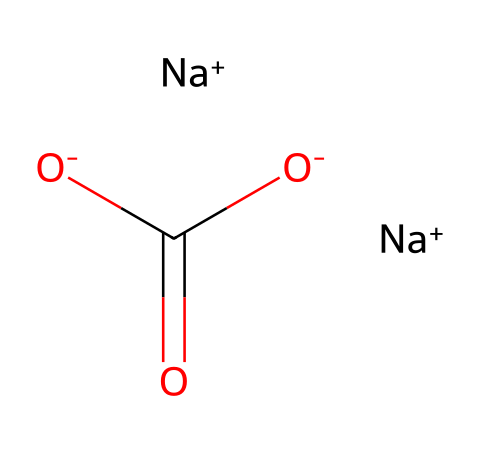What is the molecular formula of this compound? The SMILES representation indicates the arrangement and types of atoms present in the molecule. Analyzing the structure, we find two sodium atoms (Na), one carbon atom (C), and three oxygen atoms (O), leading to the formula Na2CO3.
Answer: Na2CO3 How many sodium atoms are in the compound? By examining the SMILES, there are two occurrences of the [Na+] symbol, indicating there are two sodium atoms present in the molecule.
Answer: 2 What type of chemical is sodium carbonate? Sodium carbonate is recognized primarily as a salt due to the presence of sodium ion and carbonate ion. The overall structure and its ionic nature categorize it as a salt.
Answer: salt How many total oxygen atoms are in the structure? From the SMILES representation, there are three oxygen atoms indicated by the [O-] and the O in the (C(=O)[O-]) part of the molecule. Count confirmed by the presence of one for carbon dioxide and two for the carbonate ions.
Answer: 3 Which part of the chemical structure contributes to its basicity? The presence of the carbonate ion ([O-]C(=O)[O-]) indicates that the structure can accept protons, which contributes to its basic nature, elevating the pH.
Answer: carbonate ion What is the charge on the carbonate ion in the structure? The SMILES notation shows two [O-] groups associated with carbon, indicating that the carbonate ion carries a -2 charge overall, reflecting its ability to donate protons in reactions.
Answer: -2 What role does sodium carbonate play in laundry detergents? Sodium carbonate acts as a water softener in laundry detergents, helping to remove hard water ions that interfere with the effectiveness of other cleaning agents, promoting better cleaning performance.
Answer: water softener 